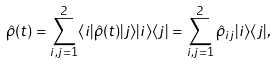<formula> <loc_0><loc_0><loc_500><loc_500>\hat { \rho } ( t ) = \sum _ { i , j = 1 } ^ { 2 } \langle i | \hat { \rho } ( t ) | j \rangle | i \rangle \langle j | = \sum _ { i , j = 1 } ^ { 2 } \hat { \rho } _ { i j } | i \rangle \langle j | ,</formula> 